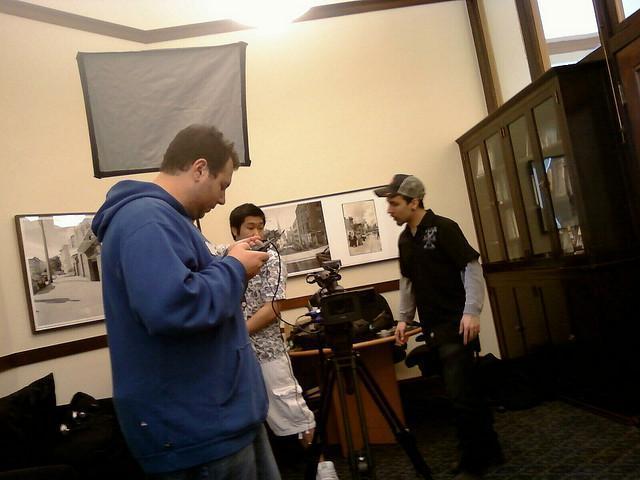How many men are in the picture?
Give a very brief answer. 3. How many people are there?
Give a very brief answer. 3. How many giraffes are inside the building?
Give a very brief answer. 0. 